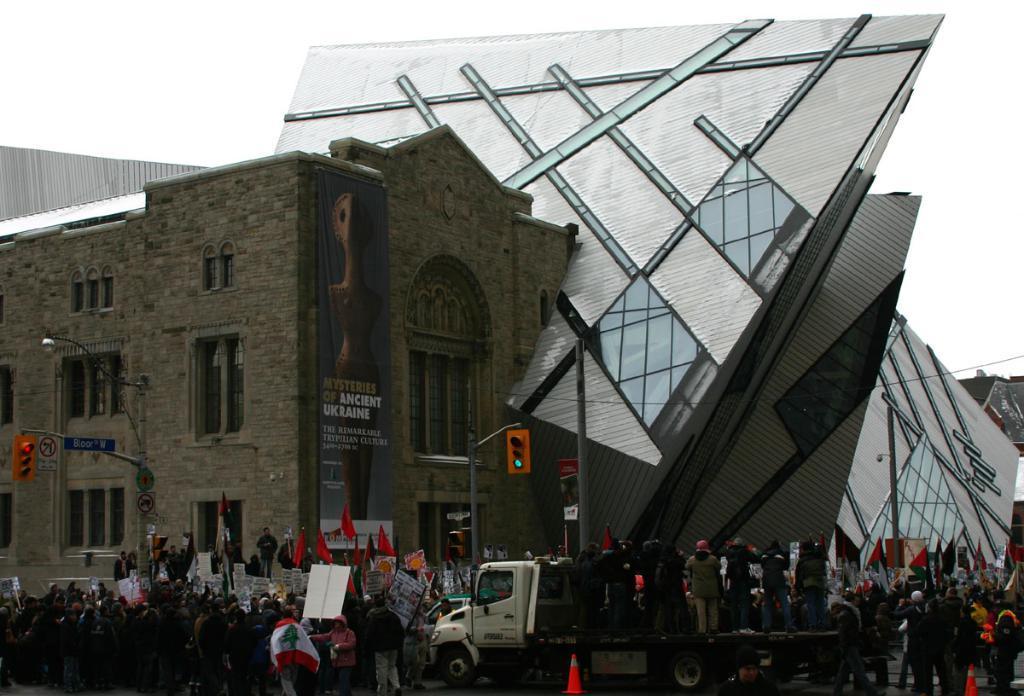In one or two sentences, can you explain what this image depicts? On the left side it is a building, in the middle few people are standing on the vehicle. 